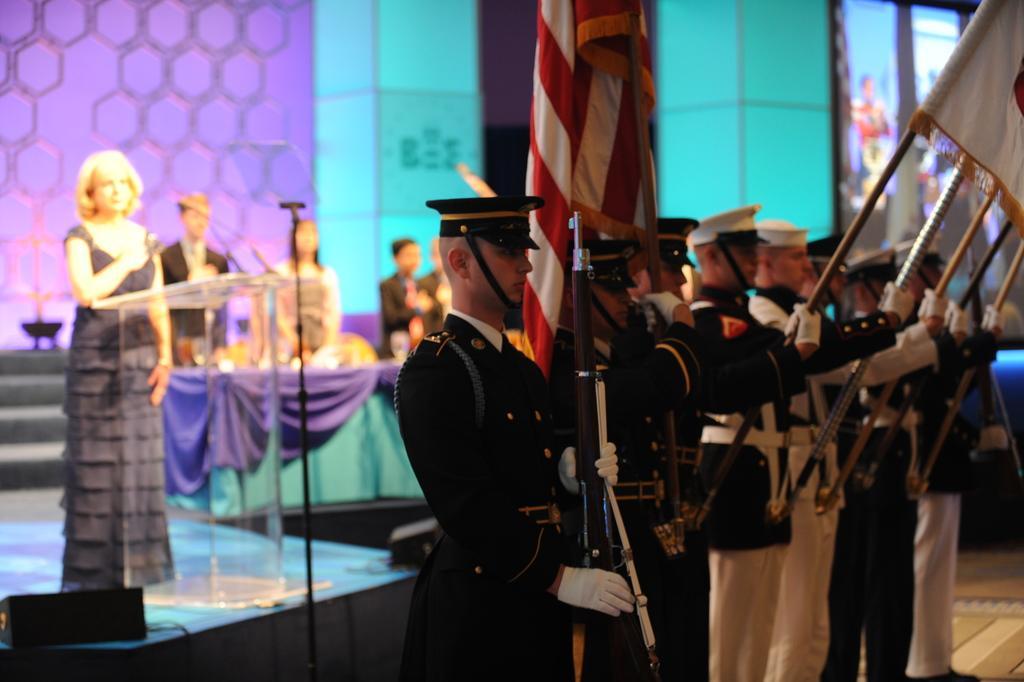Could you give a brief overview of what you see in this image? In this picture we can see some people are standing, a man in the front is holding a rifle, the persons on the right side are holding flags, on the left side there is a woman standing in front of a podium, we can see a microphone on the podium, there is a blurry background. 